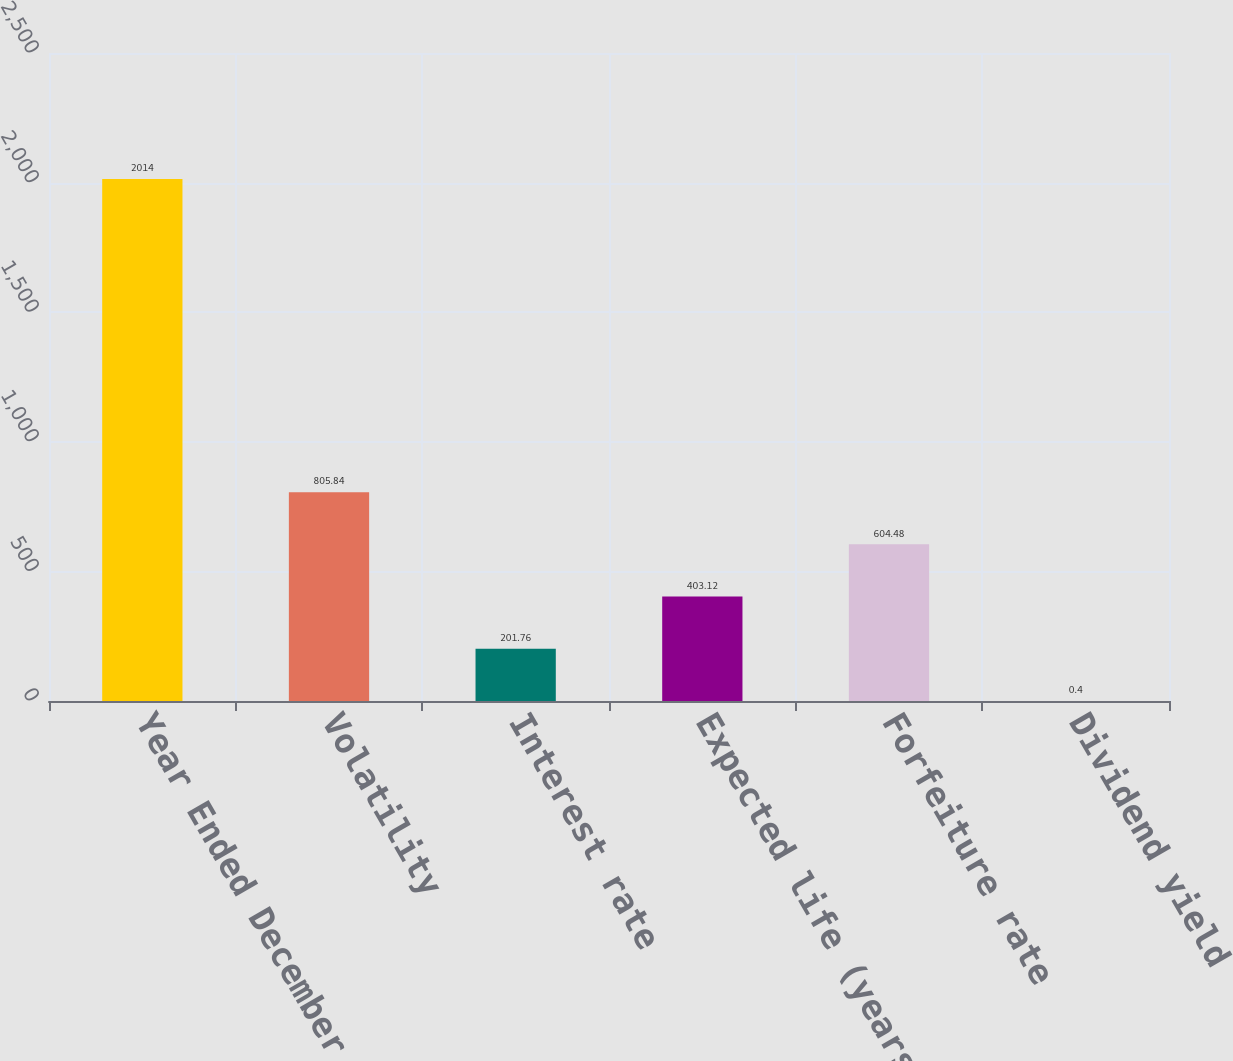<chart> <loc_0><loc_0><loc_500><loc_500><bar_chart><fcel>Year Ended December 31<fcel>Volatility<fcel>Interest rate<fcel>Expected life (years)<fcel>Forfeiture rate<fcel>Dividend yield<nl><fcel>2014<fcel>805.84<fcel>201.76<fcel>403.12<fcel>604.48<fcel>0.4<nl></chart> 